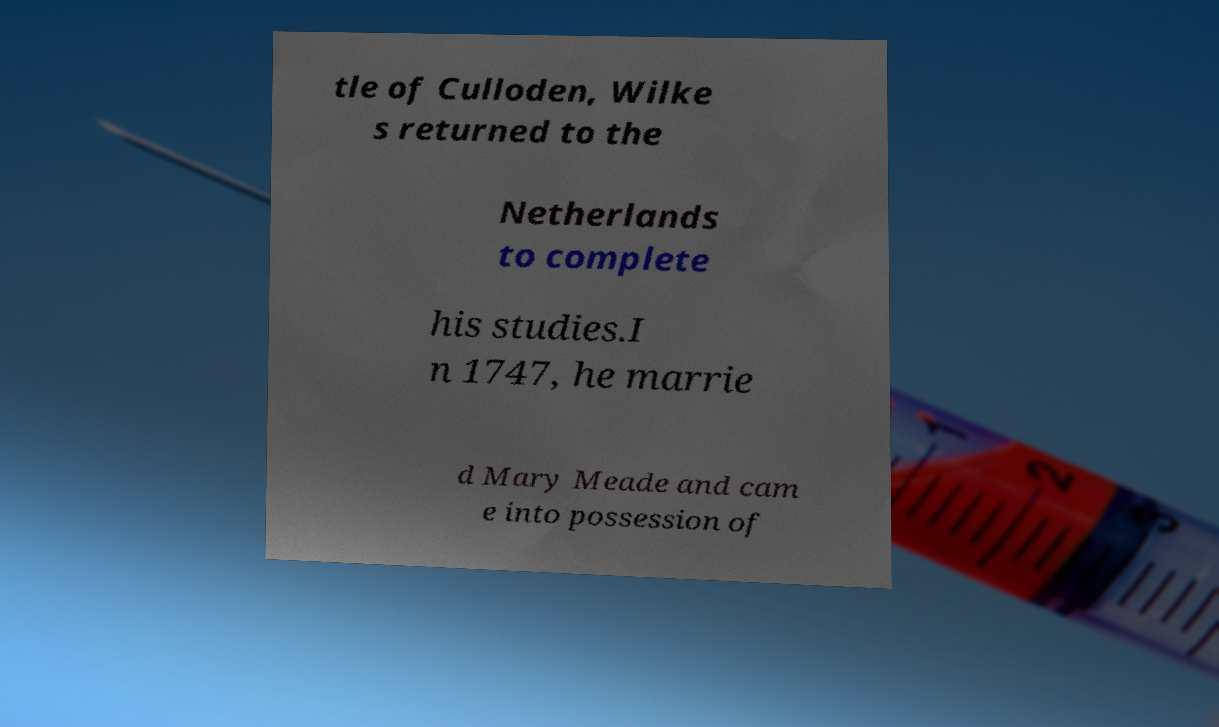I need the written content from this picture converted into text. Can you do that? tle of Culloden, Wilke s returned to the Netherlands to complete his studies.I n 1747, he marrie d Mary Meade and cam e into possession of 